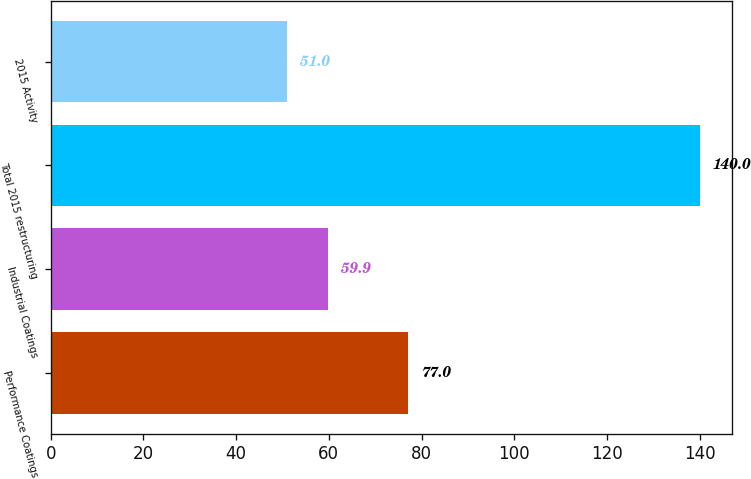<chart> <loc_0><loc_0><loc_500><loc_500><bar_chart><fcel>Performance Coatings<fcel>Industrial Coatings<fcel>Total 2015 restructuring<fcel>2015 Activity<nl><fcel>77<fcel>59.9<fcel>140<fcel>51<nl></chart> 